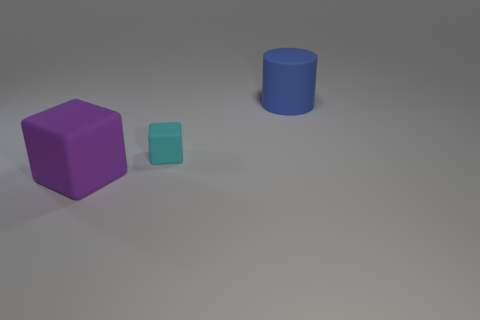Add 2 big matte cubes. How many objects exist? 5 Subtract all cubes. How many objects are left? 1 Subtract 0 gray cylinders. How many objects are left? 3 Subtract all blue objects. Subtract all big purple rubber things. How many objects are left? 1 Add 3 small cyan matte blocks. How many small cyan matte blocks are left? 4 Add 2 big gray objects. How many big gray objects exist? 2 